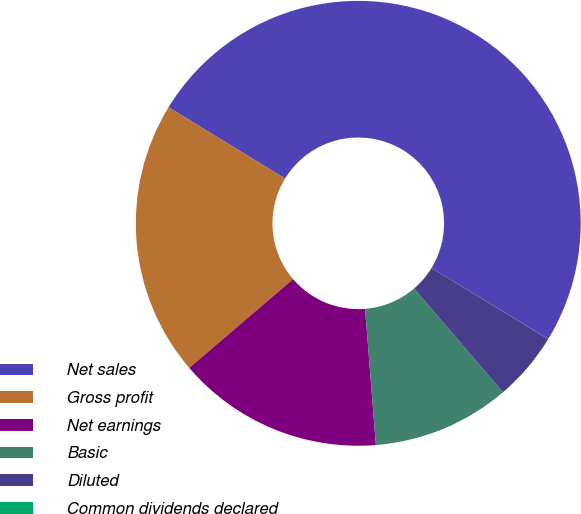<chart> <loc_0><loc_0><loc_500><loc_500><pie_chart><fcel>Net sales<fcel>Gross profit<fcel>Net earnings<fcel>Basic<fcel>Diluted<fcel>Common dividends declared<nl><fcel>49.97%<fcel>20.0%<fcel>15.0%<fcel>10.01%<fcel>5.01%<fcel>0.01%<nl></chart> 